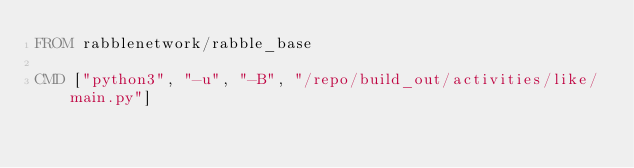Convert code to text. <code><loc_0><loc_0><loc_500><loc_500><_Dockerfile_>FROM rabblenetwork/rabble_base

CMD ["python3", "-u", "-B", "/repo/build_out/activities/like/main.py"]
</code> 